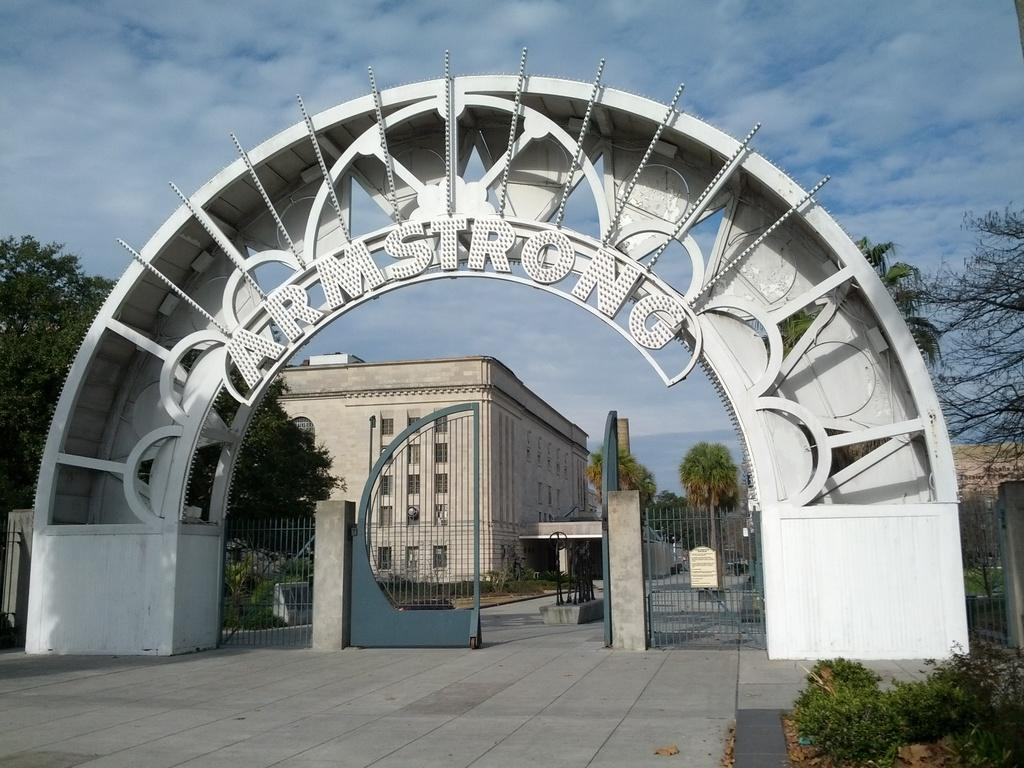What type of structures can be seen in the image? There are buildings in the image. What is the arch in the image used for? The arch in the image has text on it, which suggests it might be a sign or a decorative element. What type of barrier is present in the image? There is a metal gate in the image. What type of vegetation can be seen in the image? There are trees and plants in the image. How would you describe the sky in the image? The sky is blue and cloudy in the image. Can you tell me how many streams are visible in the image? There are no streams present in the image. Which direction is the fowl facing in the image? There are no fowl present in the image. 